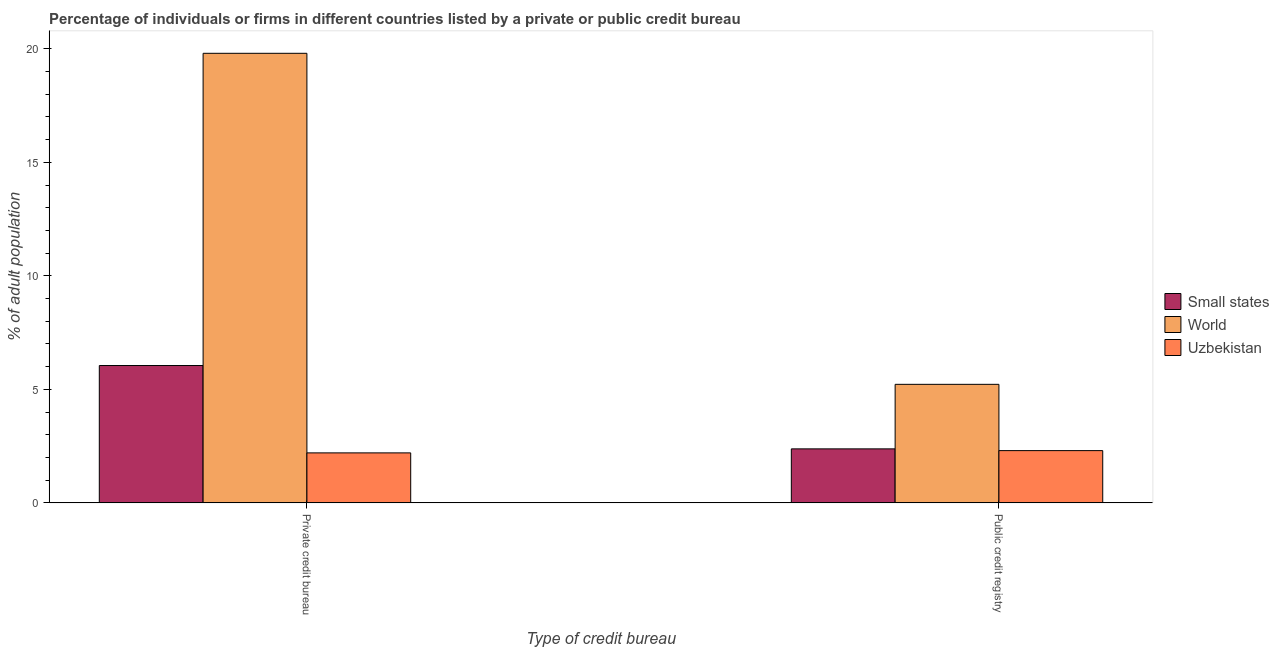How many different coloured bars are there?
Provide a short and direct response. 3. Are the number of bars per tick equal to the number of legend labels?
Offer a terse response. Yes. How many bars are there on the 2nd tick from the right?
Your response must be concise. 3. What is the label of the 2nd group of bars from the left?
Your answer should be very brief. Public credit registry. What is the percentage of firms listed by public credit bureau in Small states?
Your answer should be very brief. 2.38. Across all countries, what is the maximum percentage of firms listed by private credit bureau?
Make the answer very short. 19.8. Across all countries, what is the minimum percentage of firms listed by public credit bureau?
Give a very brief answer. 2.3. In which country was the percentage of firms listed by private credit bureau maximum?
Offer a very short reply. World. In which country was the percentage of firms listed by private credit bureau minimum?
Your answer should be very brief. Uzbekistan. What is the total percentage of firms listed by public credit bureau in the graph?
Provide a succinct answer. 9.9. What is the difference between the percentage of firms listed by public credit bureau in World and that in Uzbekistan?
Provide a succinct answer. 2.92. What is the difference between the percentage of firms listed by public credit bureau in World and the percentage of firms listed by private credit bureau in Uzbekistan?
Offer a very short reply. 3.02. What is the average percentage of firms listed by public credit bureau per country?
Your answer should be compact. 3.3. What is the difference between the percentage of firms listed by public credit bureau and percentage of firms listed by private credit bureau in World?
Ensure brevity in your answer.  -14.58. What is the ratio of the percentage of firms listed by private credit bureau in Uzbekistan to that in Small states?
Provide a short and direct response. 0.36. Is the percentage of firms listed by private credit bureau in World less than that in Small states?
Your response must be concise. No. In how many countries, is the percentage of firms listed by private credit bureau greater than the average percentage of firms listed by private credit bureau taken over all countries?
Offer a very short reply. 1. What does the 2nd bar from the left in Private credit bureau represents?
Offer a terse response. World. What does the 1st bar from the right in Private credit bureau represents?
Your answer should be very brief. Uzbekistan. How many bars are there?
Make the answer very short. 6. How many countries are there in the graph?
Provide a short and direct response. 3. What is the difference between two consecutive major ticks on the Y-axis?
Offer a terse response. 5. Are the values on the major ticks of Y-axis written in scientific E-notation?
Keep it short and to the point. No. How many legend labels are there?
Your answer should be very brief. 3. What is the title of the graph?
Offer a very short reply. Percentage of individuals or firms in different countries listed by a private or public credit bureau. Does "New Zealand" appear as one of the legend labels in the graph?
Your answer should be compact. No. What is the label or title of the X-axis?
Provide a short and direct response. Type of credit bureau. What is the label or title of the Y-axis?
Ensure brevity in your answer.  % of adult population. What is the % of adult population of Small states in Private credit bureau?
Your answer should be compact. 6.05. What is the % of adult population of World in Private credit bureau?
Make the answer very short. 19.8. What is the % of adult population in Uzbekistan in Private credit bureau?
Give a very brief answer. 2.2. What is the % of adult population of Small states in Public credit registry?
Your answer should be very brief. 2.38. What is the % of adult population in World in Public credit registry?
Ensure brevity in your answer.  5.22. Across all Type of credit bureau, what is the maximum % of adult population in Small states?
Your answer should be compact. 6.05. Across all Type of credit bureau, what is the maximum % of adult population in World?
Your response must be concise. 19.8. Across all Type of credit bureau, what is the maximum % of adult population in Uzbekistan?
Make the answer very short. 2.3. Across all Type of credit bureau, what is the minimum % of adult population of Small states?
Your answer should be compact. 2.38. Across all Type of credit bureau, what is the minimum % of adult population of World?
Your answer should be compact. 5.22. Across all Type of credit bureau, what is the minimum % of adult population of Uzbekistan?
Your answer should be very brief. 2.2. What is the total % of adult population of Small states in the graph?
Provide a succinct answer. 8.43. What is the total % of adult population in World in the graph?
Provide a succinct answer. 25.02. What is the total % of adult population in Uzbekistan in the graph?
Ensure brevity in your answer.  4.5. What is the difference between the % of adult population of Small states in Private credit bureau and that in Public credit registry?
Keep it short and to the point. 3.67. What is the difference between the % of adult population of World in Private credit bureau and that in Public credit registry?
Your answer should be compact. 14.58. What is the difference between the % of adult population in Small states in Private credit bureau and the % of adult population in World in Public credit registry?
Make the answer very short. 0.83. What is the difference between the % of adult population of Small states in Private credit bureau and the % of adult population of Uzbekistan in Public credit registry?
Your answer should be compact. 3.75. What is the difference between the % of adult population of World in Private credit bureau and the % of adult population of Uzbekistan in Public credit registry?
Your response must be concise. 17.5. What is the average % of adult population of Small states per Type of credit bureau?
Offer a very short reply. 4.21. What is the average % of adult population in World per Type of credit bureau?
Provide a short and direct response. 12.51. What is the average % of adult population in Uzbekistan per Type of credit bureau?
Provide a succinct answer. 2.25. What is the difference between the % of adult population in Small states and % of adult population in World in Private credit bureau?
Offer a terse response. -13.75. What is the difference between the % of adult population in Small states and % of adult population in Uzbekistan in Private credit bureau?
Offer a terse response. 3.85. What is the difference between the % of adult population in World and % of adult population in Uzbekistan in Private credit bureau?
Give a very brief answer. 17.6. What is the difference between the % of adult population of Small states and % of adult population of World in Public credit registry?
Offer a terse response. -2.84. What is the difference between the % of adult population of Small states and % of adult population of Uzbekistan in Public credit registry?
Your answer should be very brief. 0.08. What is the difference between the % of adult population in World and % of adult population in Uzbekistan in Public credit registry?
Offer a very short reply. 2.92. What is the ratio of the % of adult population in Small states in Private credit bureau to that in Public credit registry?
Provide a short and direct response. 2.54. What is the ratio of the % of adult population in World in Private credit bureau to that in Public credit registry?
Your answer should be very brief. 3.79. What is the ratio of the % of adult population of Uzbekistan in Private credit bureau to that in Public credit registry?
Provide a succinct answer. 0.96. What is the difference between the highest and the second highest % of adult population of Small states?
Offer a very short reply. 3.67. What is the difference between the highest and the second highest % of adult population in World?
Give a very brief answer. 14.58. What is the difference between the highest and the lowest % of adult population of Small states?
Make the answer very short. 3.67. What is the difference between the highest and the lowest % of adult population in World?
Provide a short and direct response. 14.58. What is the difference between the highest and the lowest % of adult population of Uzbekistan?
Your answer should be compact. 0.1. 